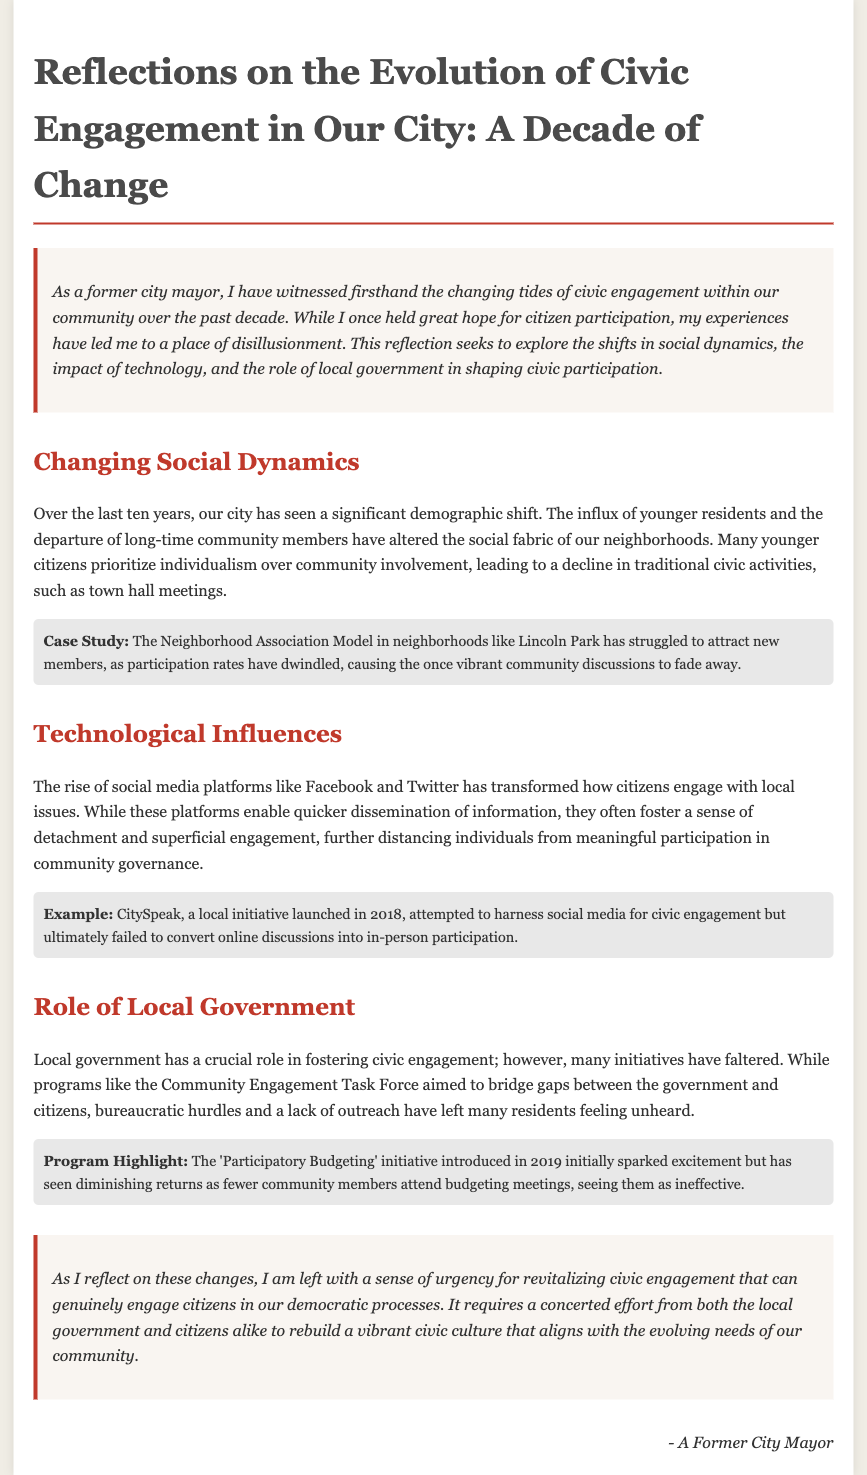What has changed in the city's demographics over the past decade? The document mentions an influx of younger residents and the departure of long-time community members, altering the social fabric of neighborhoods.
Answer: Shifts in demographics What initiative was launched in 2018 to enhance civic engagement? The document references "CitySpeak," a local initiative aimed at harnessing social media for civic engagement.
Answer: CitySpeak What example illustrates the struggle of neighborhood associations in the document? The note highlights the Neighborhood Association Model in Lincoln Park struggling to attract new members due to dwindling participation rates.
Answer: Lincoln Park Association Model What year was the 'Participatory Budgeting' initiative introduced? The document states that the 'Participatory Budgeting' initiative was introduced in 2019.
Answer: 2019 What sentiment does the former mayor express about civic engagement? The reflection conveys a sense of urgency for revitalizing civic engagement among citizens and local government.
Answer: Urgency for revitalizing What is one challenge faced by the Community Engagement Task Force? The document indicates that bureaucratic hurdles and a lack of outreach have hampered the effectiveness of the Community Engagement Task Force.
Answer: Bureaucratic hurdles What has been the effect of social media on civic participation according to the document? The document suggests that while social media enables quick information dissemination, it often leads to a sense of detachment from meaningful civic engagement.
Answer: Detachment What program is highlighted as having initially sparked excitement but saw diminishing returns? The text mentions the 'Participatory Budgeting' initiative as having had diminishing returns in community attendance.
Answer: Participatory Budgeting 